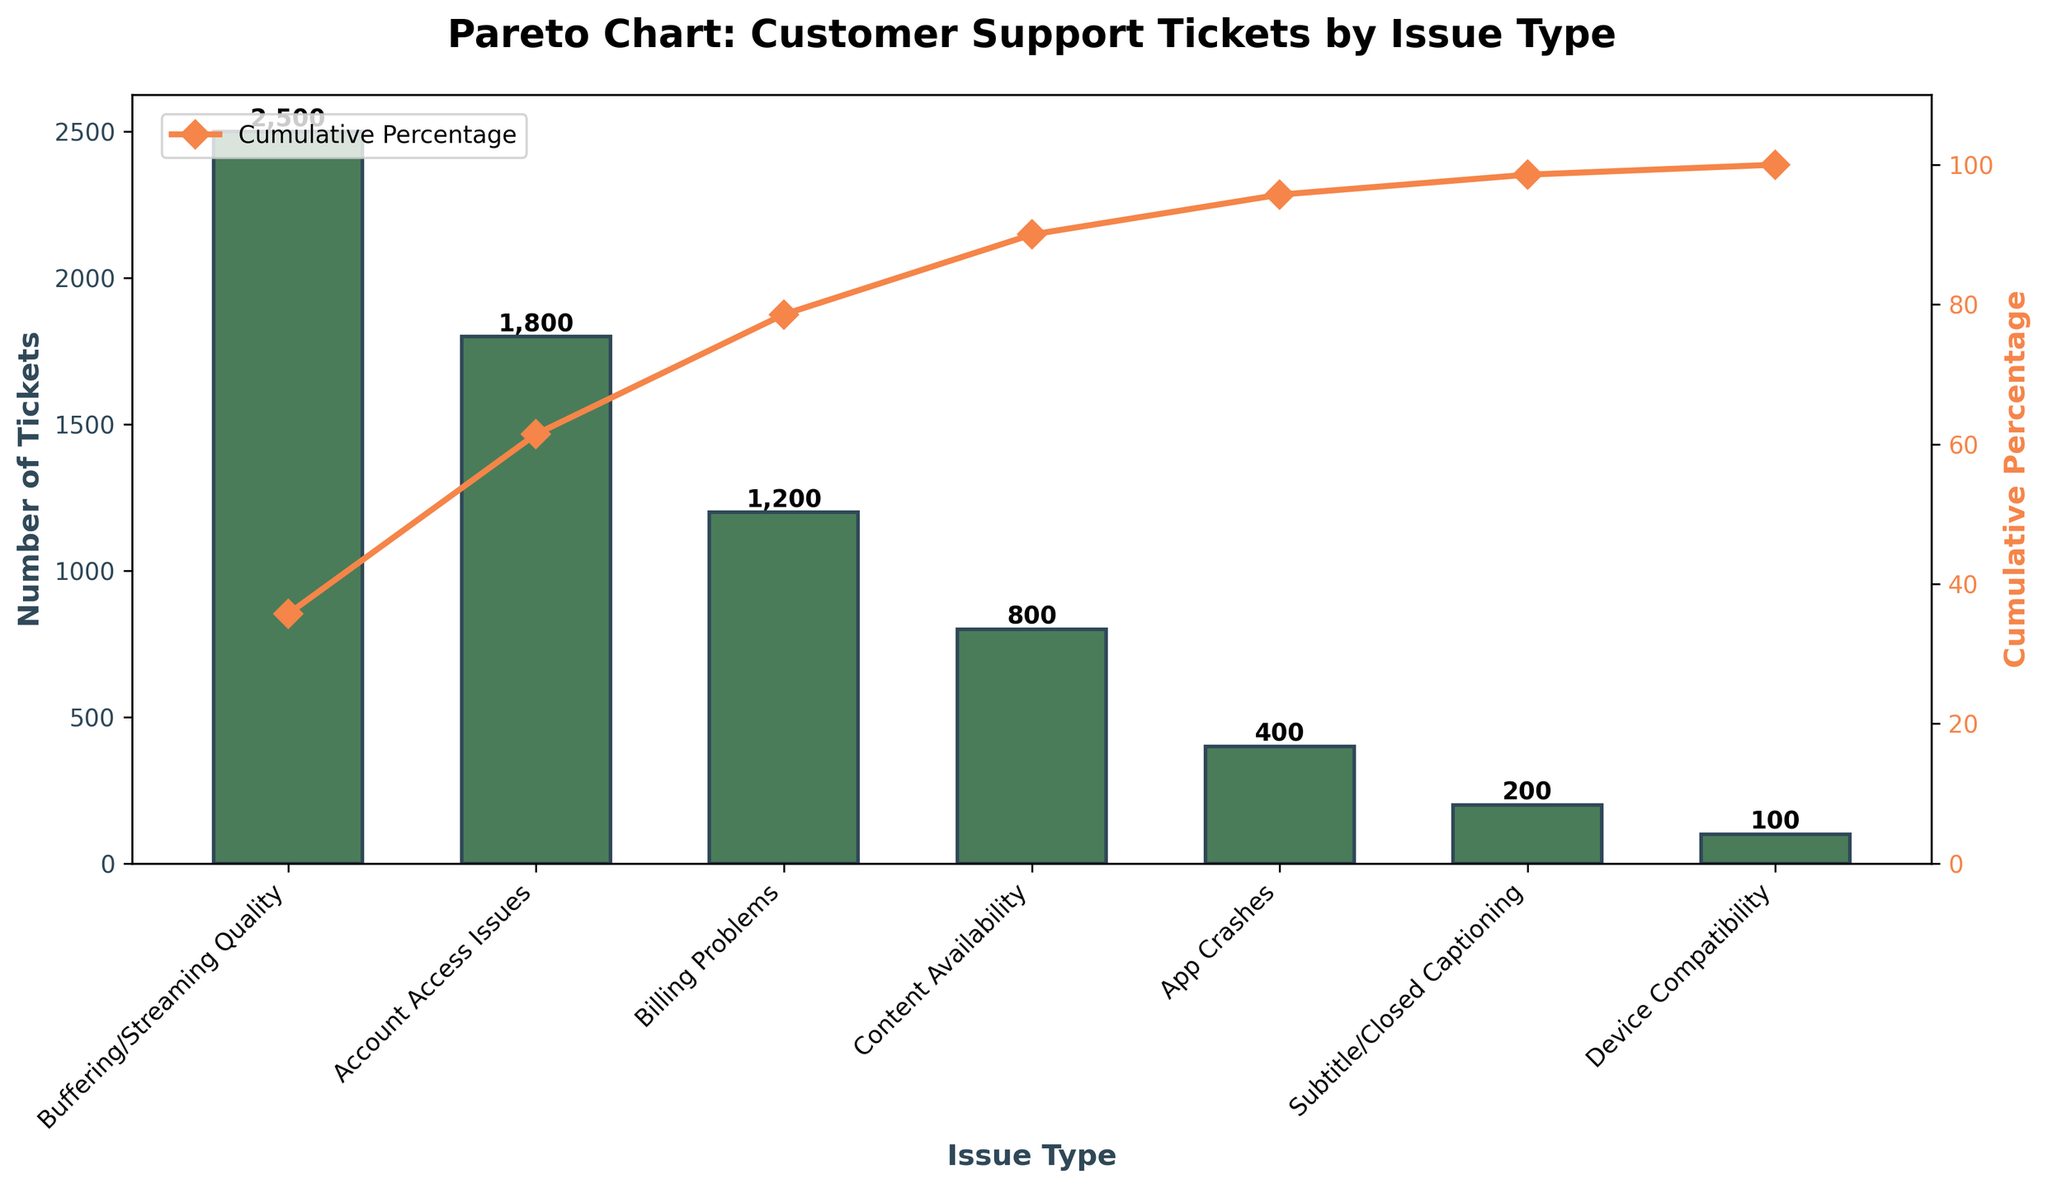What is the title of the figure? The title of the figure is usually located at the top and describes the overall content of the chart. Here, it says "Pareto Chart: Customer Support Tickets by Issue Type".
Answer: Pareto Chart: Customer Support Tickets by Issue Type What issue type has the highest number of tickets? The bars represent the number of tickets for each issue type. The tallest bar corresponds to "Buffering/Streaming Quality".
Answer: Buffering/Streaming Quality What is the cumulative percentage after adding Account Access Issues? The cumulative percentage is shown by the orange line and points. For Account Access Issues, the cumulative percentage is 61.43%.
Answer: 61.43% What is the combined total of tickets for Account Access Issues and Billing Problems? The number of tickets for Account Access Issues is 1,800 and Billing Problems is 1,200. Adding these together gives 1,800 + 1,200 = 3,000.
Answer: 3,000 Which issue type has the smallest number of tickets and what is the count? The shortest bar represents the fewest tickets. For Device Compatibility, it shows 100 tickets.
Answer: Device Compatibility, 100 How many issue types contribute to reaching a cumulative percentage of 78.57%? Observing the cumulative percentage line, 78.57% is reached after the first three bars: Buffering/Streaming Quality, Account Access Issues, and Billing Problems.
Answer: 3 By how much do tickets for Buffering/Streaming Quality exceed those for App Crashes? The tickets for Buffering/Streaming Quality are 2,500 and for App Crashes are 400. The difference is 2,500 - 400 = 2,100.
Answer: 2,100 What types of customer issues make up more than 90% of all tickets when combined? The cumulative percentage hits 90% after the first four issue types: Buffering/Streaming Quality, Account Access Issues, Billing Problems, and Content Availability.
Answer: Buffering/Streaming Quality, Account Access Issues, Billing Problems, Content Availability What is the cumulative percentage for Subtitle/Closed Captioning and does it reach above 95%? For the issue "Subtitle/Closed Captioning", the cumulative percentage is 98.57%, which is above 95%.
Answer: 98.57%, Yes 